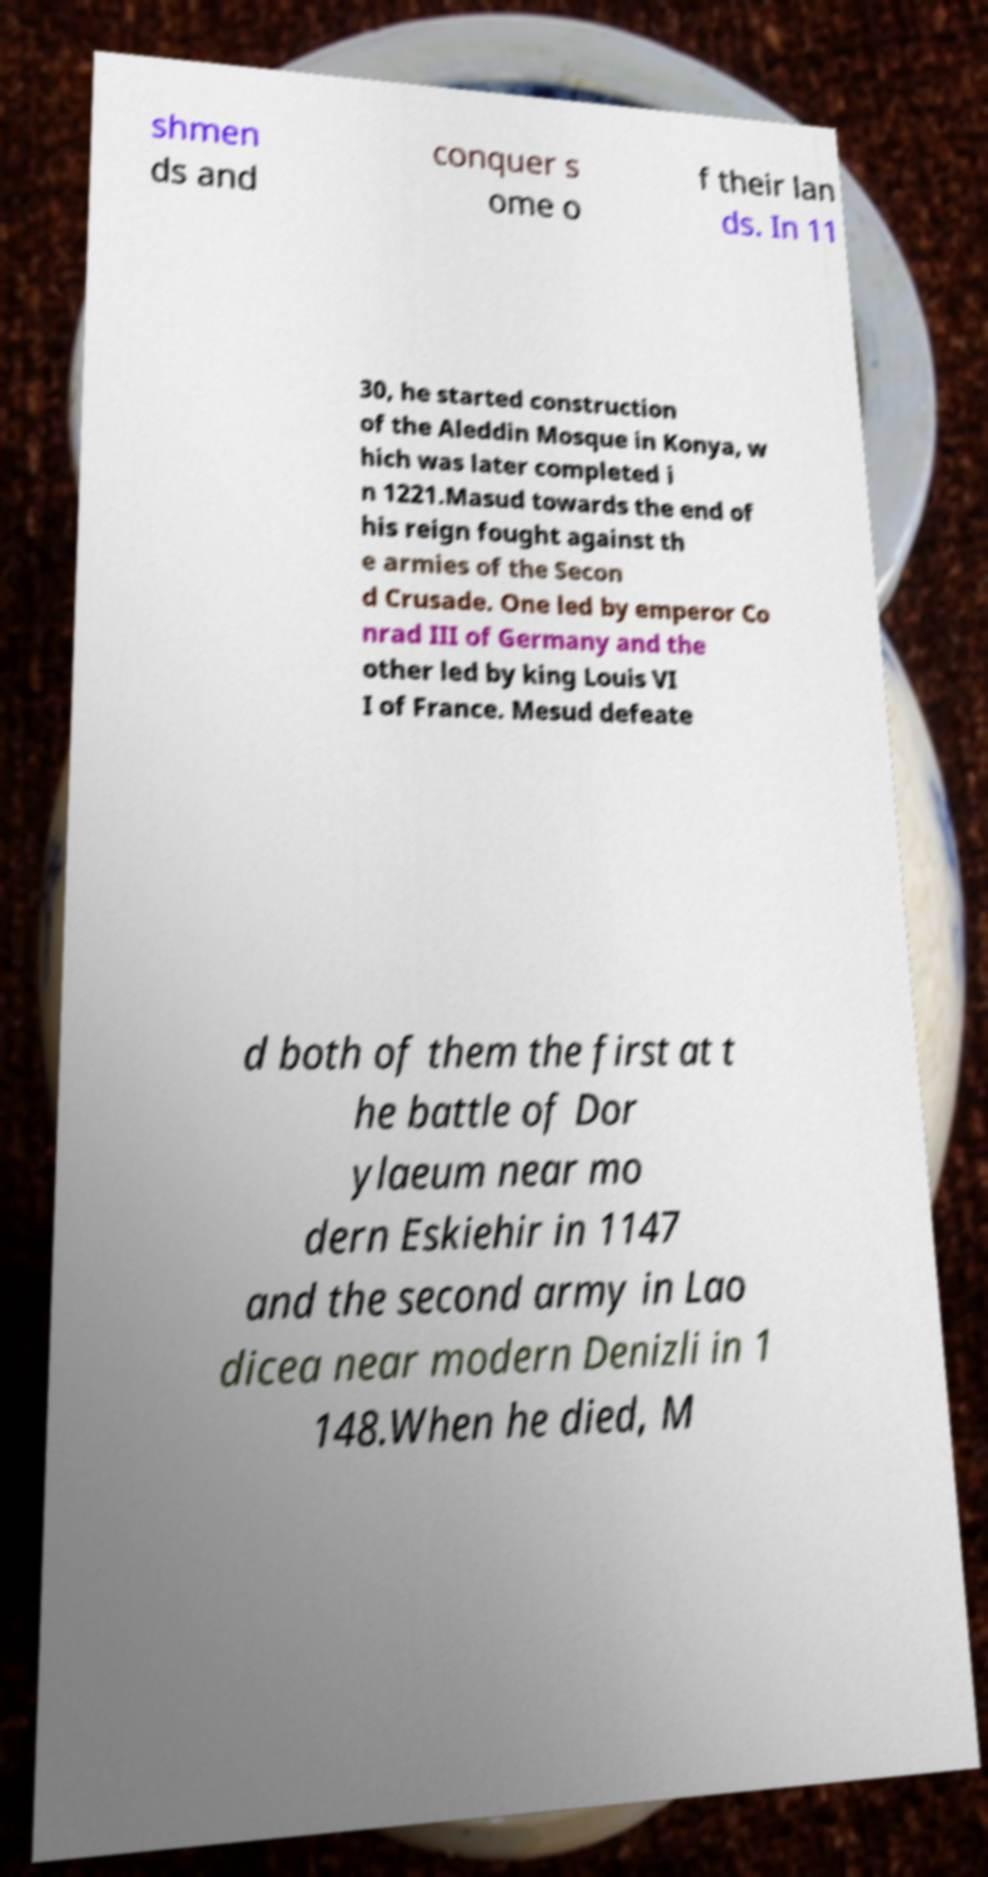Can you read and provide the text displayed in the image?This photo seems to have some interesting text. Can you extract and type it out for me? shmen ds and conquer s ome o f their lan ds. In 11 30, he started construction of the Aleddin Mosque in Konya, w hich was later completed i n 1221.Masud towards the end of his reign fought against th e armies of the Secon d Crusade. One led by emperor Co nrad III of Germany and the other led by king Louis VI I of France. Mesud defeate d both of them the first at t he battle of Dor ylaeum near mo dern Eskiehir in 1147 and the second army in Lao dicea near modern Denizli in 1 148.When he died, M 